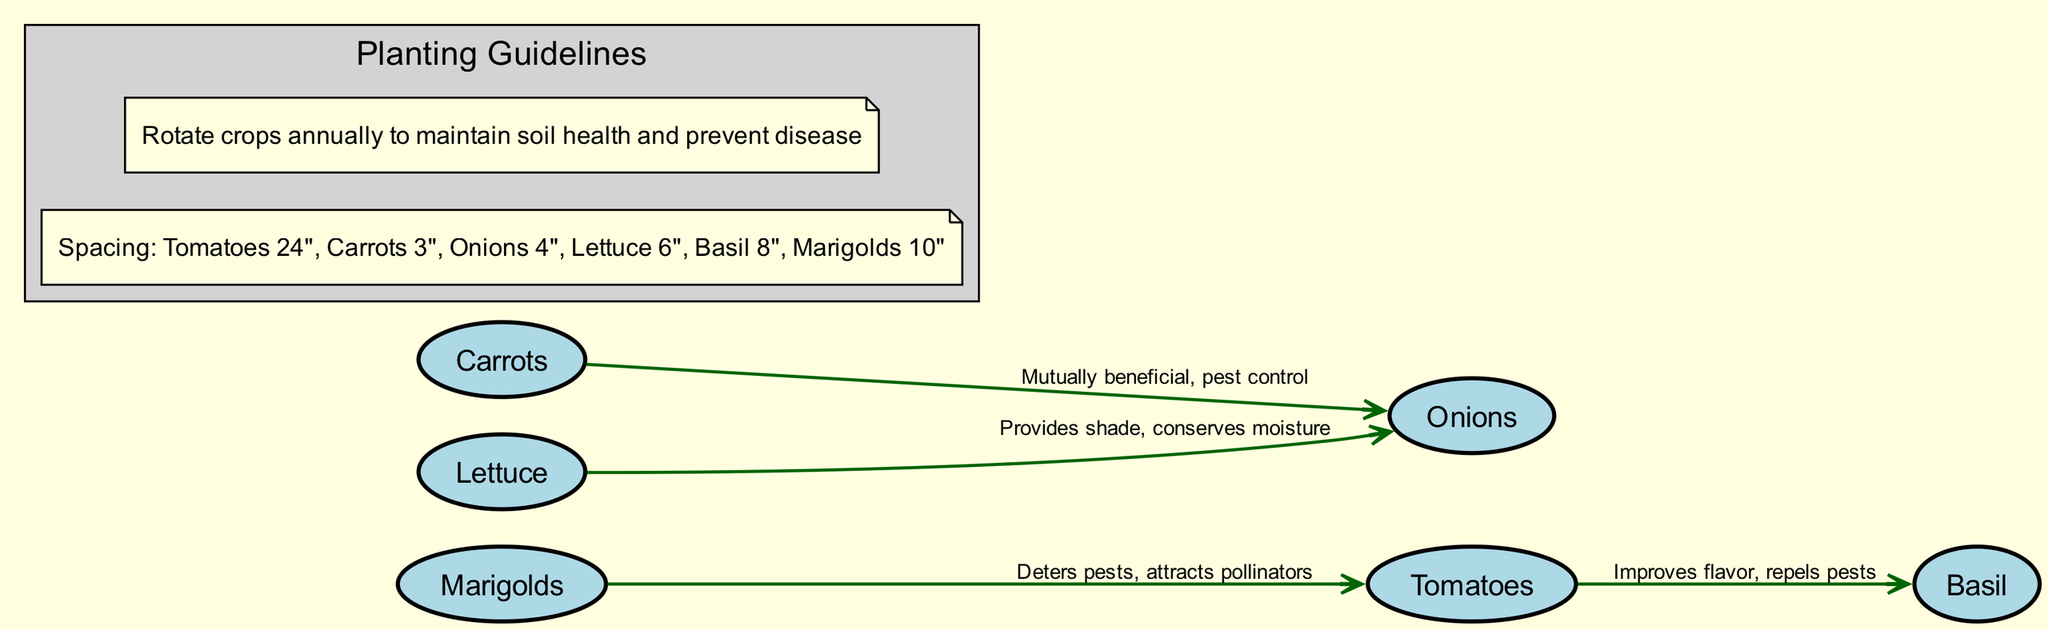What is the relationship between tomatoes and basil? The edge connecting the nodes for tomatoes and basil states that basil "improves flavor" and "repels pests." This indicates that the presence of basil is beneficial when planted alongside tomatoes.
Answer: Improves flavor, repels pests How many nodes are in the diagram? The diagram lists six different nodes: tomatoes, basil, carrots, onions, lettuce, and marigolds. Counting these gives a total of six nodes.
Answer: 6 What type of flower is indicated to deter pests for tomatoes? The diagram has an edge leading from marigolds to tomatoes, stating that marigolds "deter pests" and "attract pollinators." This means marigolds are the noted flower for pest deterrence.
Answer: Marigolds What is the spacing recommended for carrots? The annotations section lists the spacing for carrots as 3 inches. This information specifies how far apart carrots should be planted in the garden.
Answer: 3 inches Which two plants are mutually beneficial and help in pest control? The edge between carrots and onions mentions they are "mutually beneficial" and assist in pest control, indicating these two plants support each other in their growth and pest management.
Answer: Carrots and onions What does lettuce provide to onions? The diagram specifies that lettuce "provides shade" and "conserves moisture" for onions. This implies that growing lettuce can have a positive effect on the growth conditions for onions.
Answer: Provides shade, conserves moisture How far apart should marigolds be planted? According to the spacing annotation, marigolds should be planted 10 inches apart, specifying the spacing requirement necessary for effective growth.
Answer: 10 inches What is a recommended practice for crop rotation? The note in the diagram advises to "rotate crops annually" to maintain soil health and prevent disease, which helps keep the garden productive and healthy over time.
Answer: Rotate crops annually 